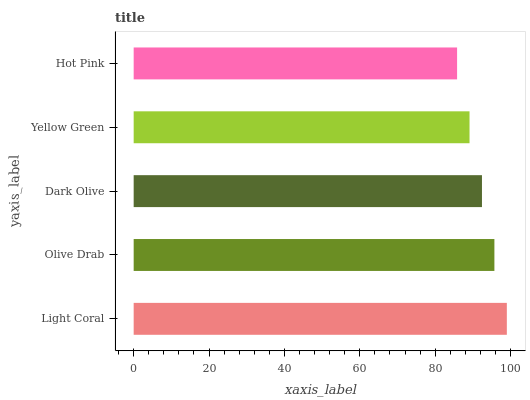Is Hot Pink the minimum?
Answer yes or no. Yes. Is Light Coral the maximum?
Answer yes or no. Yes. Is Olive Drab the minimum?
Answer yes or no. No. Is Olive Drab the maximum?
Answer yes or no. No. Is Light Coral greater than Olive Drab?
Answer yes or no. Yes. Is Olive Drab less than Light Coral?
Answer yes or no. Yes. Is Olive Drab greater than Light Coral?
Answer yes or no. No. Is Light Coral less than Olive Drab?
Answer yes or no. No. Is Dark Olive the high median?
Answer yes or no. Yes. Is Dark Olive the low median?
Answer yes or no. Yes. Is Light Coral the high median?
Answer yes or no. No. Is Light Coral the low median?
Answer yes or no. No. 